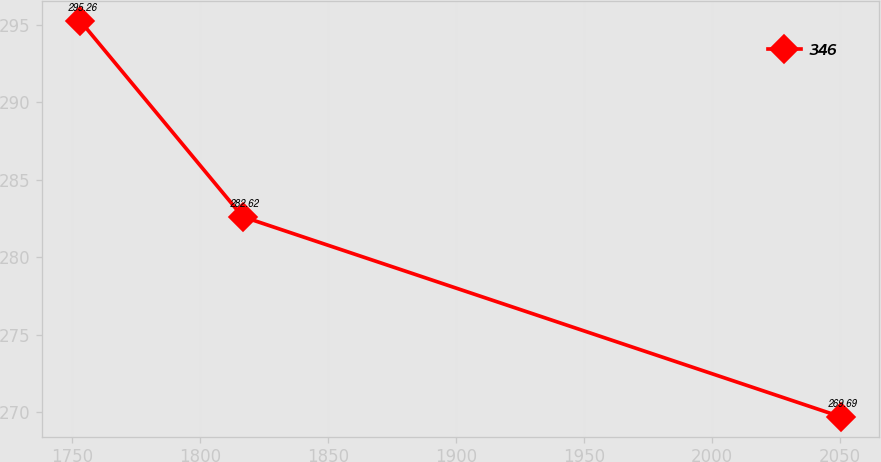Convert chart. <chart><loc_0><loc_0><loc_500><loc_500><line_chart><ecel><fcel>346<nl><fcel>1753.37<fcel>295.26<nl><fcel>1816.71<fcel>282.62<nl><fcel>2050.16<fcel>269.69<nl></chart> 